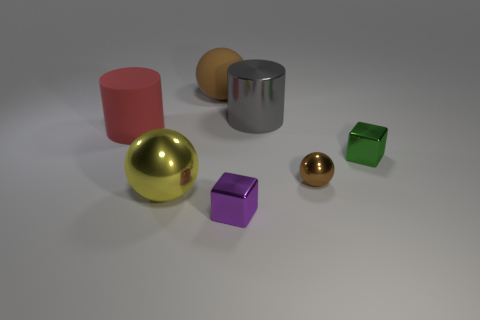How could the lighting conditions in the image influence its interpretation? The soft and diffuse lighting in the image creates minimal shadows, giving a calm and neutral atmosphere. This lighting can influence the interpretation by not emphasizing any particular object, allowing all objects to be viewed equally, and it could be considered as a neutral setup for product photography or a visual examination scenario. 